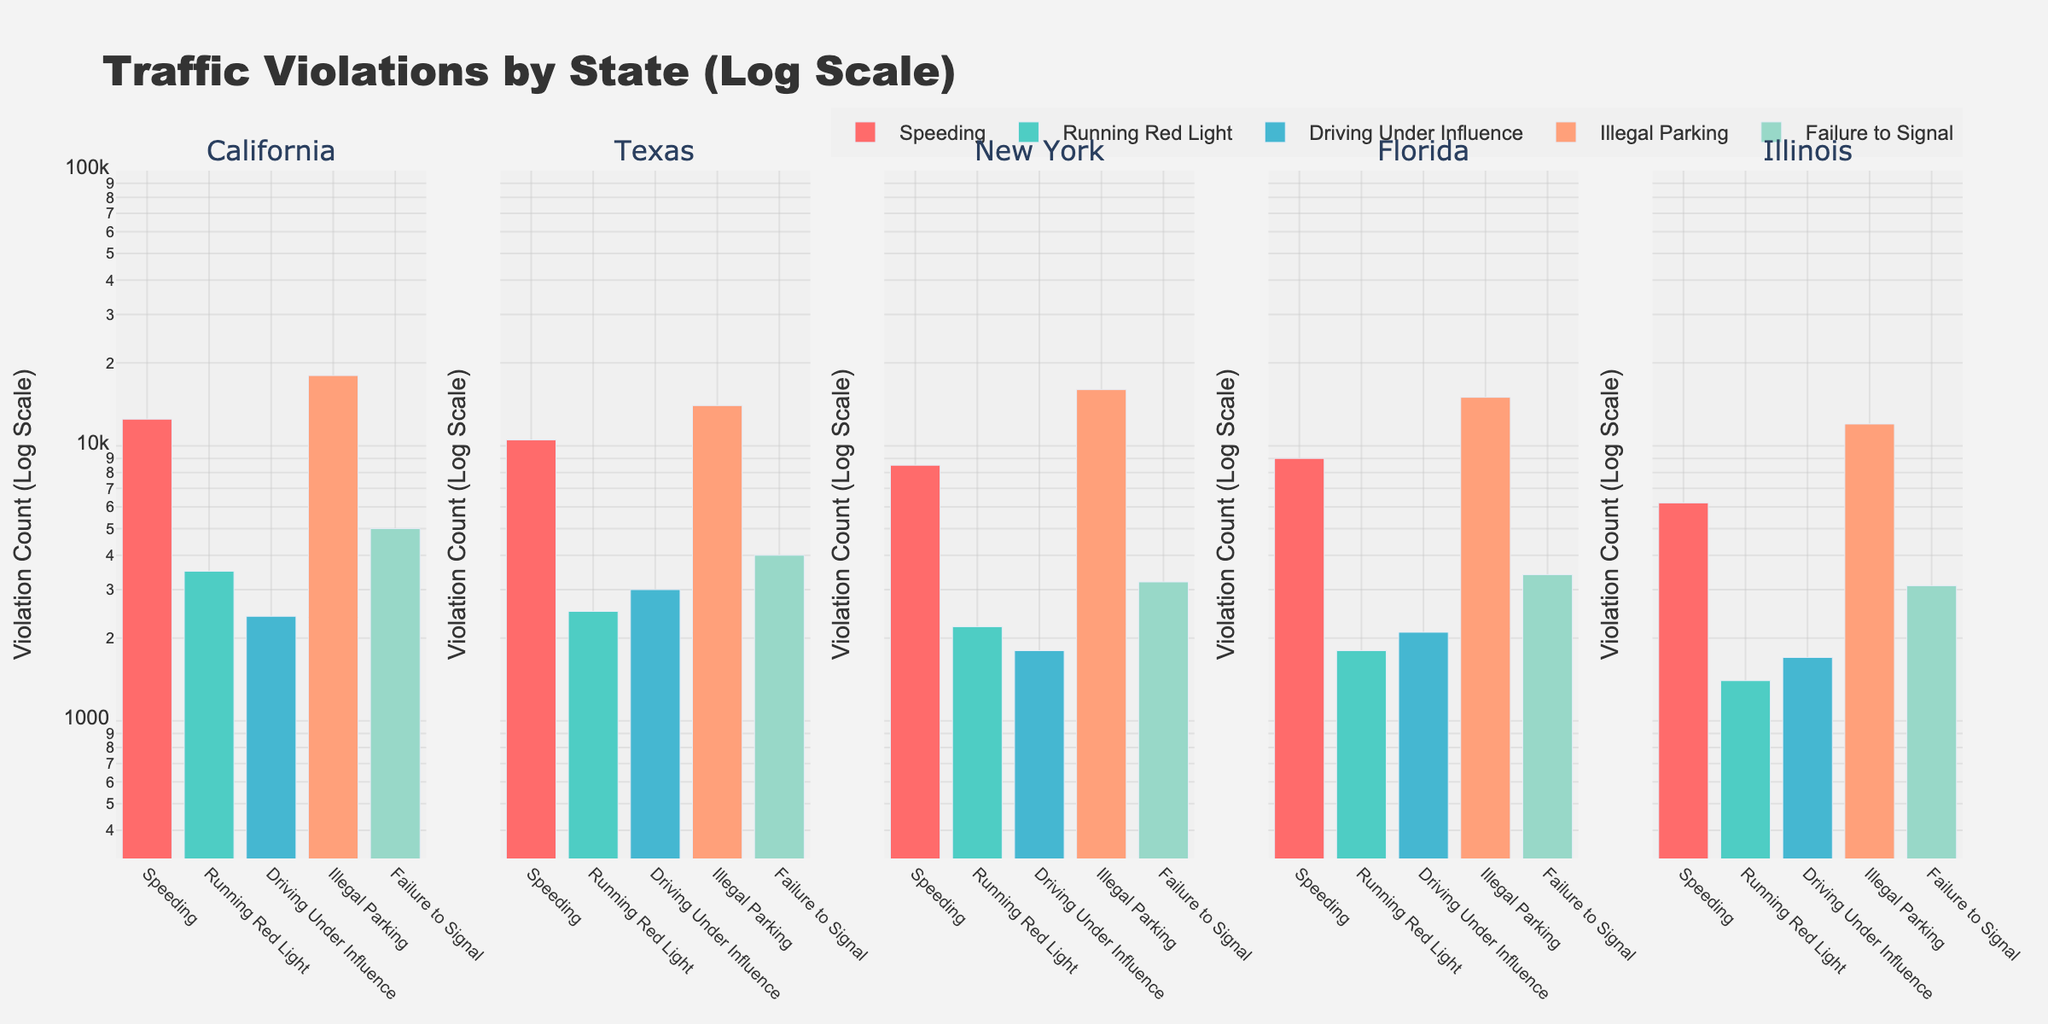What is the main title of the figure? The main title is displayed prominently at the top center of the figure in a larger, bold font which indicates the general subject of the figure.
Answer: Traffic Violations by State (Log Scale) How many different states are represented in the subplots? Each subplot corresponds to a different state, and by counting the subplot titles, we can determine the number of states.
Answer: 5 Which state has the highest number of Illegal Parking violations? By comparing the height of the bars representing Illegal Parking across all subplots, we find the tallest bar.
Answer: California What is the difference in the count of Speeding violations between Texas and Illinois? Comparing the log-scale bars for Speeding in the Texas and Illinois subplots, we subtract the violation counts to find the difference.
Answer: 4300 How many traffic violation categories are shown in each subplot? Each subplot displays bars representing different traffic violation categories. By counting these bars in one subplot, we find the number.
Answer: 5 Which traffic violation has the lowest frequency in Florida? Identifying the shortest bar in the Florida subplot, we determine the traffic violation category for that bar.
Answer: Running Red Light Rank the states from highest to lowest number of Failure to Signal violations. By comparing the heights of the bars for Failure to Signal violations in each subplot, we order the states accordingly.
Answer: California, Florida, Texas, Illinois, New York What is the log-scale range used for the y-axis? Observing the y-axis labels and range specifies the logarithmic scale from minimum to maximum values.
Answer: 2.5 to 5 Which state has the greatest variability in traffic violation counts? By examining each state's subplot and comparing the range of bar heights (violations), we identify the state with the widest range.
Answer: California Are there any states with identical counts for any specific violation categories? Checking each subplot for traffic violation bars that have the same height across different states to identify any such instances.
Answer: No 